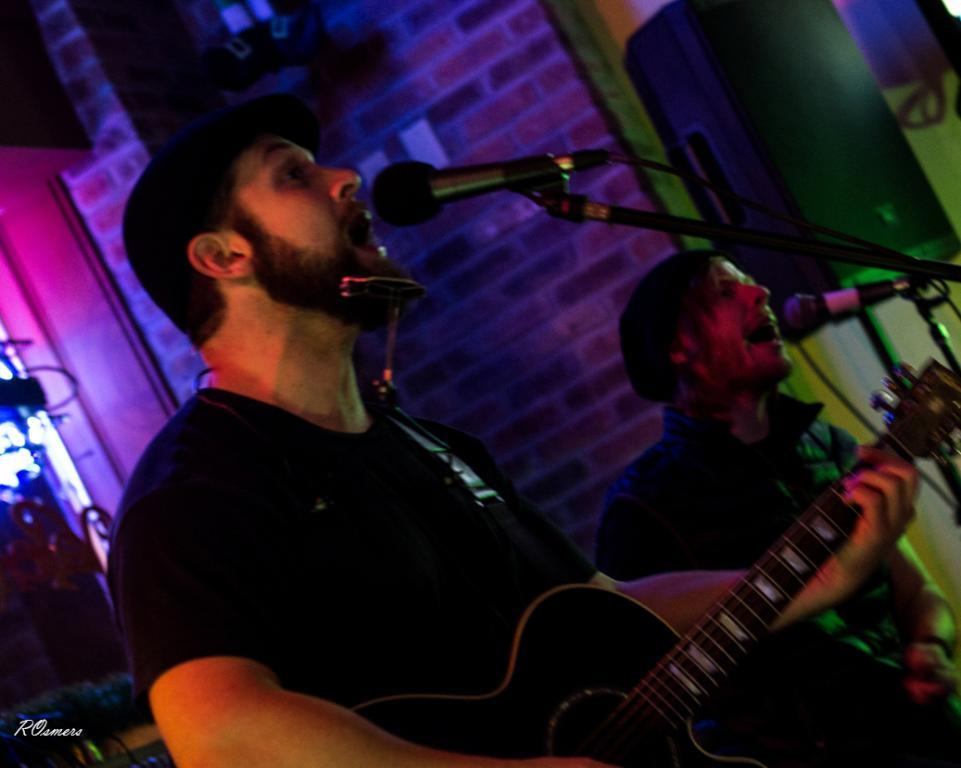How many people are in the image? There are two men in the image. What is one of the men holding? One man is holding a guitar. What are both men doing in the image? Both men are singing. How are they amplifying their voices? They are using microphones. What can be seen in the background of the image? There is a wall, speakers, and lighting in the background. What type of haircut does the man with the guitar have in the image? There is no information about the man's haircut in the image. What team do the two men belong to in the image? There is no indication of a team affiliation in the image. 